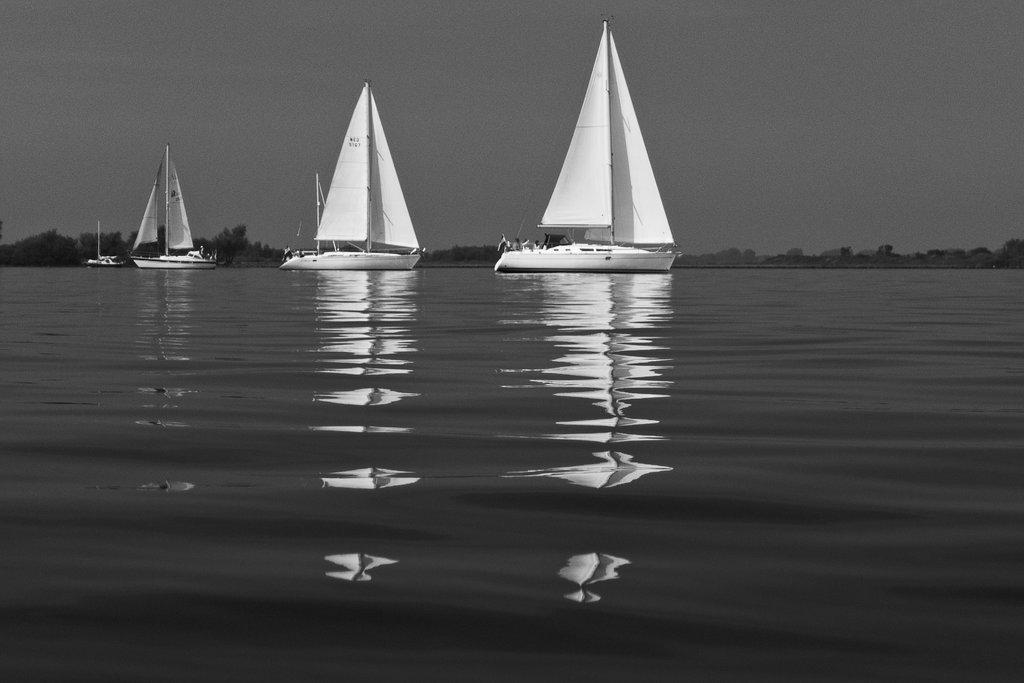What is happening in the image? There are boats sailing on the water in the image. What can be seen in the background of the image? There are trees visible in the background of the image. How many boats are sailing in the image? The number of boats cannot be determined from the provided facts. What type of design can be seen on the church in the image? There is no church present in the image; it features boats sailing on the water and trees in the background. 